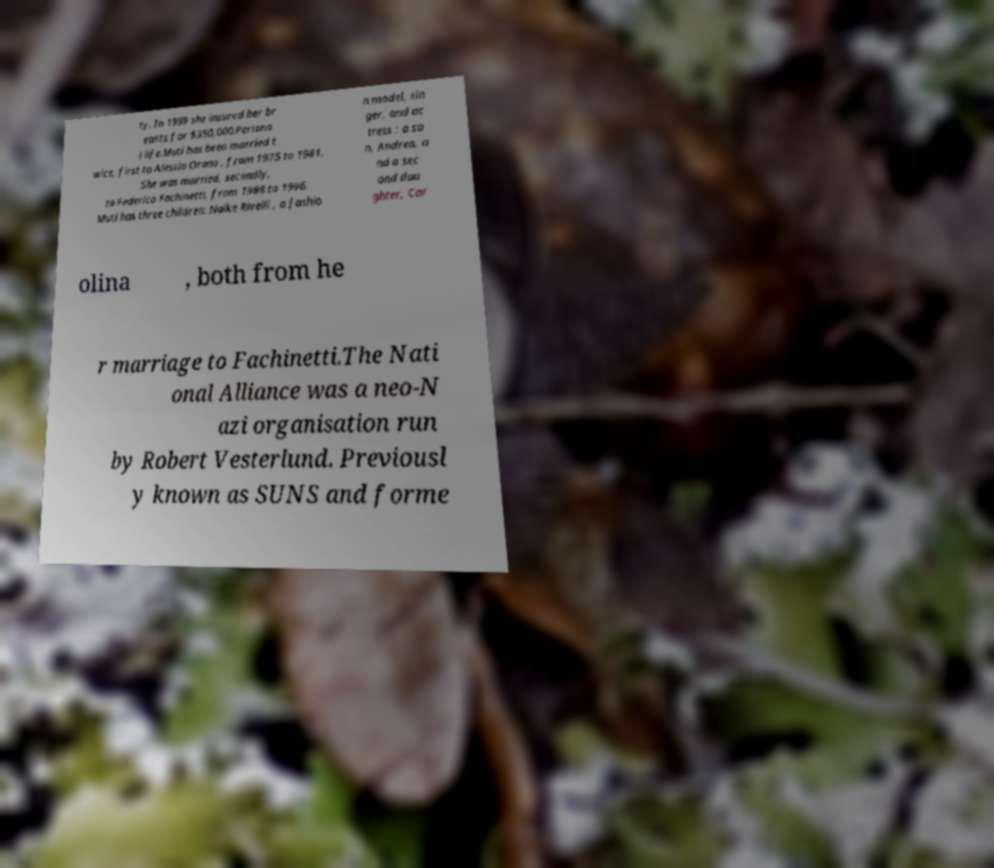Can you accurately transcribe the text from the provided image for me? ty. In 1999 she insured her br easts for $350,000.Persona l life.Muti has been married t wice, first to Alessio Orano , from 1975 to 1981. She was married, secondly, to Federico Fachinetti, from 1988 to 1996. Muti has three children: Naike Rivelli , a fashio n model, sin ger, and ac tress ; a so n, Andrea, a nd a sec ond dau ghter, Car olina , both from he r marriage to Fachinetti.The Nati onal Alliance was a neo-N azi organisation run by Robert Vesterlund. Previousl y known as SUNS and forme 